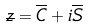Convert formula to latex. <formula><loc_0><loc_0><loc_500><loc_500>\overline { z } = \overline { C } + i \overline { S }</formula> 